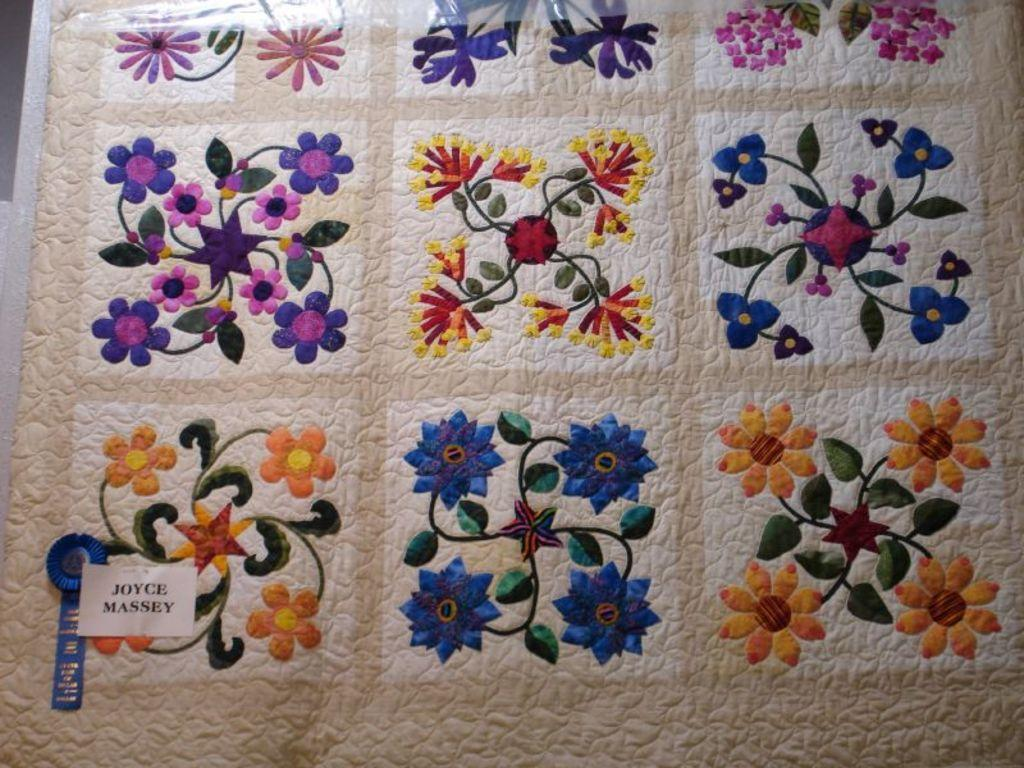What is the main feature of the object in the image? The object has different types of designs. Is there any additional information about the object? Yes, the object has a tag. What else can be seen on the object? There is a text written on a paper and pasted on the object. Can you see any celery or furniture in the image? No, there is no celery or furniture present in the image. Is there a tiger in the image? No, there is no tiger present in the image. 